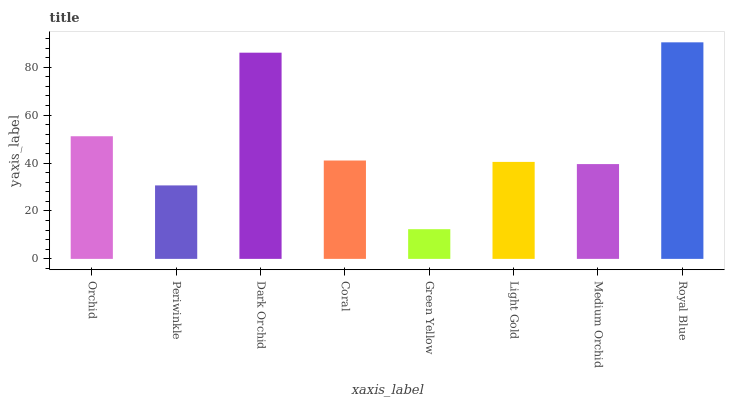Is Green Yellow the minimum?
Answer yes or no. Yes. Is Royal Blue the maximum?
Answer yes or no. Yes. Is Periwinkle the minimum?
Answer yes or no. No. Is Periwinkle the maximum?
Answer yes or no. No. Is Orchid greater than Periwinkle?
Answer yes or no. Yes. Is Periwinkle less than Orchid?
Answer yes or no. Yes. Is Periwinkle greater than Orchid?
Answer yes or no. No. Is Orchid less than Periwinkle?
Answer yes or no. No. Is Coral the high median?
Answer yes or no. Yes. Is Light Gold the low median?
Answer yes or no. Yes. Is Dark Orchid the high median?
Answer yes or no. No. Is Orchid the low median?
Answer yes or no. No. 